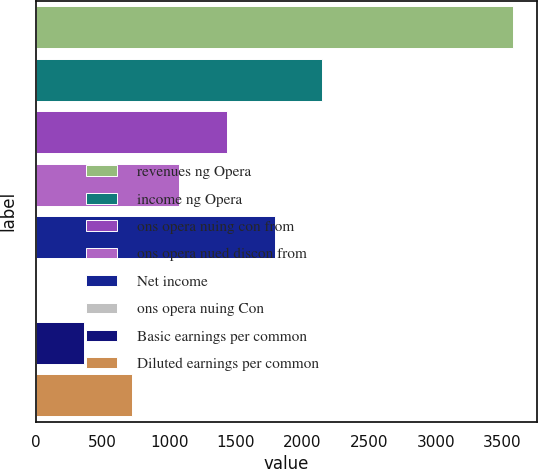Convert chart. <chart><loc_0><loc_0><loc_500><loc_500><bar_chart><fcel>revenues ng Opera<fcel>income ng Opera<fcel>ons opera nuing con from<fcel>ons opera nued discon from<fcel>Net income<fcel>ons opera nuing Con<fcel>Basic earnings per common<fcel>Diluted earnings per common<nl><fcel>3579<fcel>2147.88<fcel>1432.3<fcel>1074.51<fcel>1790.09<fcel>1.14<fcel>358.93<fcel>716.72<nl></chart> 